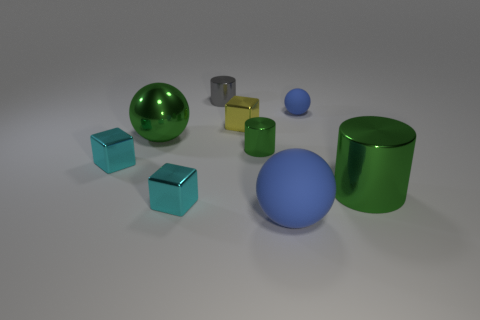There is a gray thing that is made of the same material as the small green cylinder; what is its shape?
Your answer should be compact. Cylinder. There is a green thing left of the gray cylinder; is it the same size as the blue matte ball in front of the tiny blue matte object?
Your response must be concise. Yes. What color is the small metal cylinder in front of the green shiny sphere?
Provide a succinct answer. Green. What material is the tiny cyan object that is to the right of the green metallic thing on the left side of the gray metallic object?
Your response must be concise. Metal. The big matte thing has what shape?
Your answer should be very brief. Sphere. There is a tiny green object that is the same shape as the small gray metal object; what is its material?
Provide a short and direct response. Metal. What number of blue objects are the same size as the yellow shiny cube?
Provide a succinct answer. 1. There is a shiny cylinder in front of the small green cylinder; are there any small green things that are on the right side of it?
Provide a short and direct response. No. How many yellow things are tiny metal objects or big metallic things?
Offer a terse response. 1. The big matte object is what color?
Ensure brevity in your answer.  Blue. 